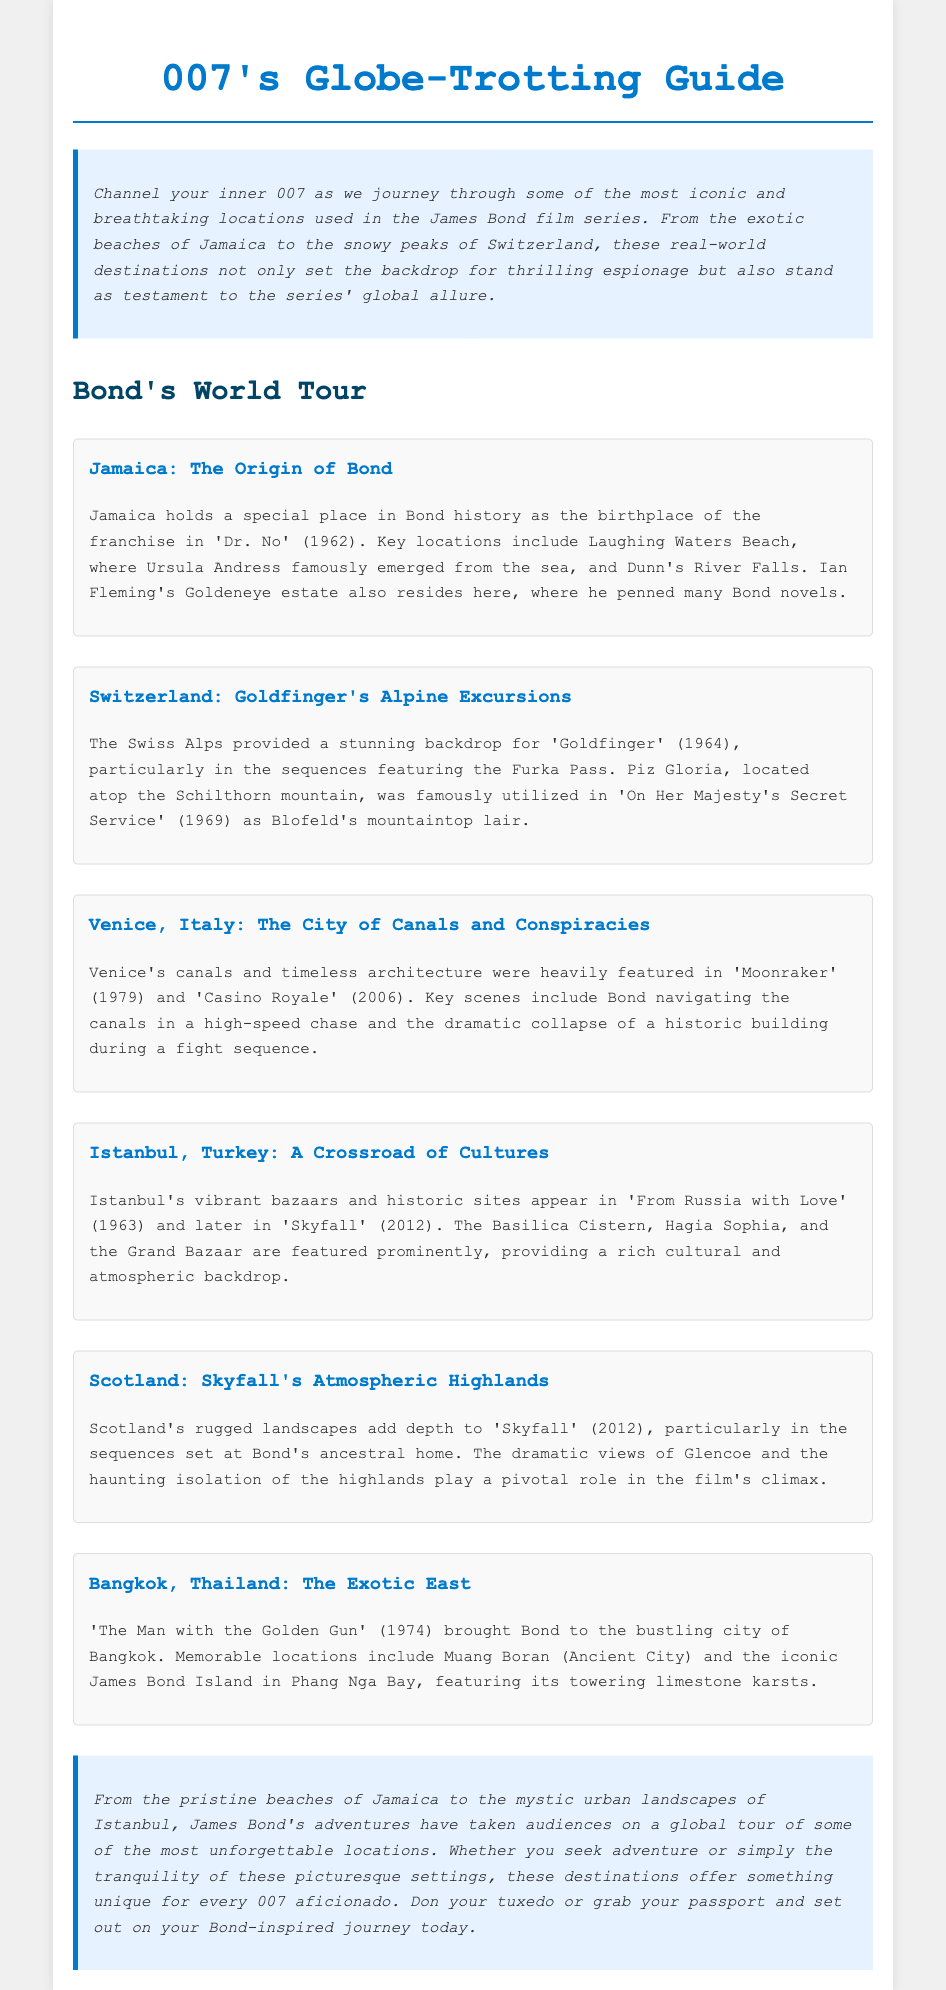what is the first film mentioned in the guide? The first film mentioned in relation to Jamaica is 'Dr. No' (1962).
Answer: 'Dr. No' (1962) which location served as Blofeld's mountaintop lair? Piz Gloria, located atop the Schilthorn mountain, served as Blofeld's lair in 'On Her Majesty's Secret Service' (1969).
Answer: Piz Gloria what year was 'Goldfinger' released? The release year of 'Goldfinger' is 1964.
Answer: 1964 name one key location featured in Istanbul. The Basilica Cistern is one of the key locations featured in Istanbul.
Answer: Basilica Cistern how many major locations from the films are described in the document? The document describes six major locations used in the James Bond films.
Answer: six what themes are highlighted by the locations in the document? The locations highlight themes of adventure and global allure.
Answer: adventure and global allure what is the tone of the introduction? The tone of the introduction is inviting and adventurous, encouraging readers to explore.
Answer: inviting and adventurous which film features a high-speed chase in Venice? 'Casino Royale' (2006) features a high-speed chase in Venice.
Answer: 'Casino Royale' (2006) what color is used for the headings throughout the document? The headings are in a blue color, specifically #007acc.
Answer: blue 